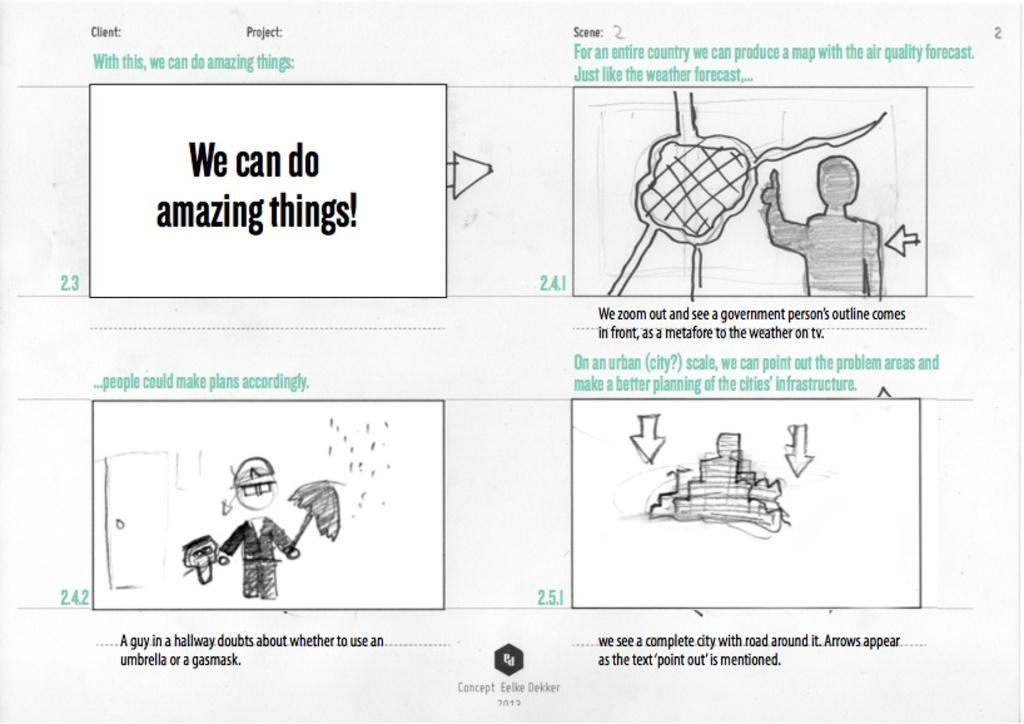Can you describe this image briefly? In this picture we can see a paper poster. In the front there is a paper with some drawing and matter written on it. 